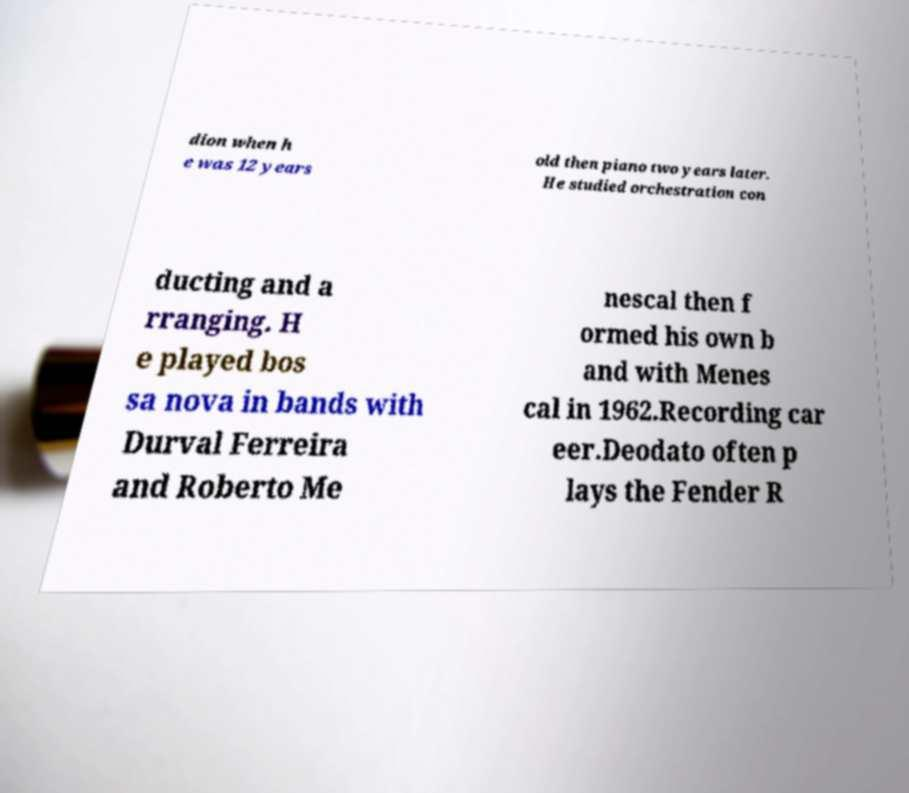Please read and relay the text visible in this image. What does it say? dion when h e was 12 years old then piano two years later. He studied orchestration con ducting and a rranging. H e played bos sa nova in bands with Durval Ferreira and Roberto Me nescal then f ormed his own b and with Menes cal in 1962.Recording car eer.Deodato often p lays the Fender R 